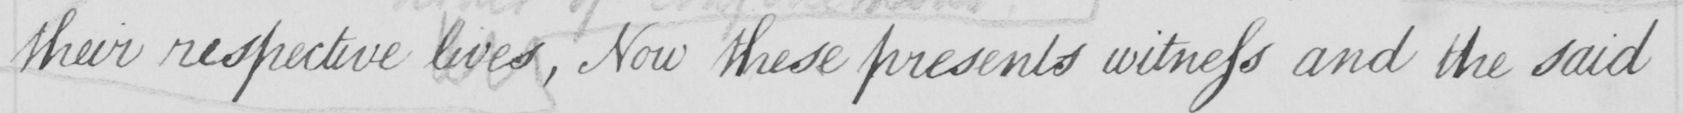Can you read and transcribe this handwriting? their respective lives , Now these presents witness and the said 